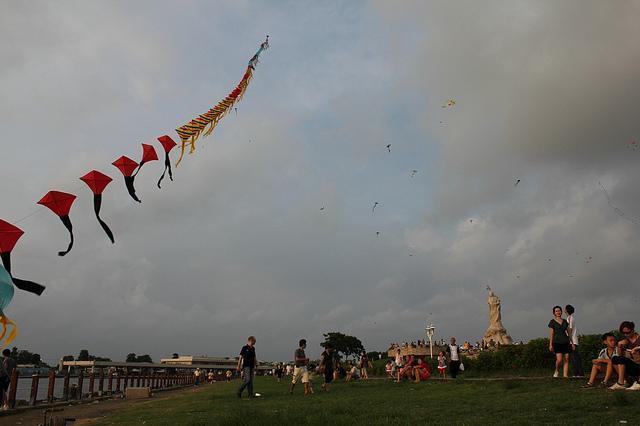How many kites are there?
Give a very brief answer. 2. 